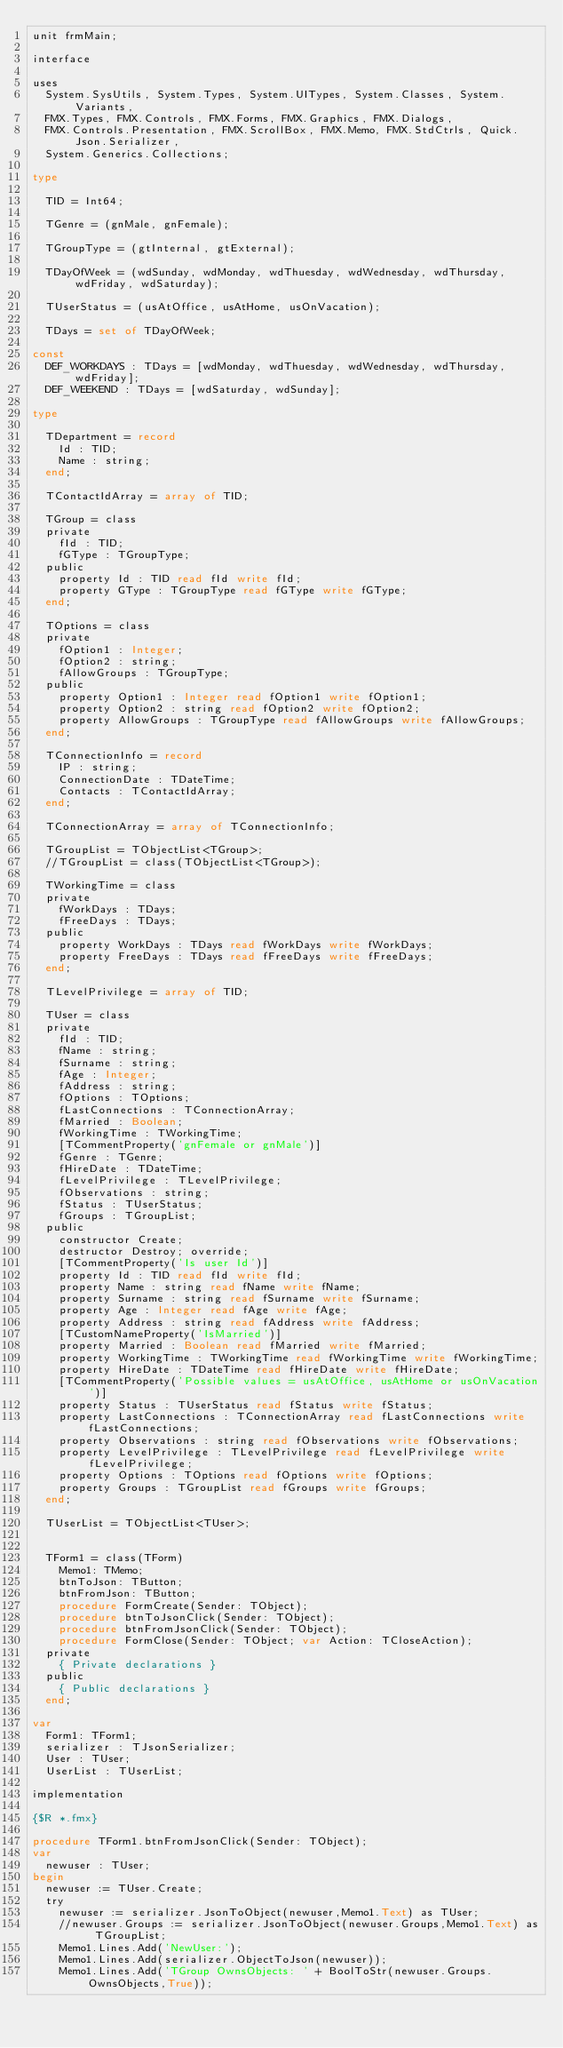Convert code to text. <code><loc_0><loc_0><loc_500><loc_500><_Pascal_>unit frmMain;

interface

uses
  System.SysUtils, System.Types, System.UITypes, System.Classes, System.Variants,
  FMX.Types, FMX.Controls, FMX.Forms, FMX.Graphics, FMX.Dialogs,
  FMX.Controls.Presentation, FMX.ScrollBox, FMX.Memo, FMX.StdCtrls, Quick.Json.Serializer,
  System.Generics.Collections;

type

  TID = Int64;

  TGenre = (gnMale, gnFemale);

  TGroupType = (gtInternal, gtExternal);

  TDayOfWeek = (wdSunday, wdMonday, wdThuesday, wdWednesday, wdThursday, wdFriday, wdSaturday);

  TUserStatus = (usAtOffice, usAtHome, usOnVacation);

  TDays = set of TDayOfWeek;

const
  DEF_WORKDAYS : TDays = [wdMonday, wdThuesday, wdWednesday, wdThursday, wdFriday];
  DEF_WEEKEND : TDays = [wdSaturday, wdSunday];

type

  TDepartment = record
    Id : TID;
    Name : string;
  end;

  TContactIdArray = array of TID;

  TGroup = class
  private
    fId : TID;
    fGType : TGroupType;
  public
    property Id : TID read fId write fId;
    property GType : TGroupType read fGType write fGType;
  end;

  TOptions = class
  private
    fOption1 : Integer;
    fOption2 : string;
    fAllowGroups : TGroupType;
  public
    property Option1 : Integer read fOption1 write fOption1;
    property Option2 : string read fOption2 write fOption2;
    property AllowGroups : TGroupType read fAllowGroups write fAllowGroups;
  end;

  TConnectionInfo = record
    IP : string;
    ConnectionDate : TDateTime;
    Contacts : TContactIdArray;
  end;

  TConnectionArray = array of TConnectionInfo;

  TGroupList = TObjectList<TGroup>;
  //TGroupList = class(TObjectList<TGroup>);

  TWorkingTime = class
  private
    fWorkDays : TDays;
    fFreeDays : TDays;
  public
    property WorkDays : TDays read fWorkDays write fWorkDays;
    property FreeDays : TDays read fFreeDays write fFreeDays;
  end;

  TLevelPrivilege = array of TID;

  TUser = class
  private
    fId : TID;
    fName : string;
    fSurname : string;
    fAge : Integer;
    fAddress : string;
    fOptions : TOptions;
    fLastConnections : TConnectionArray;
    fMarried : Boolean;
    fWorkingTime : TWorkingTime;
    [TCommentProperty('gnFemale or gnMale')]
    fGenre : TGenre;
    fHireDate : TDateTime;
    fLevelPrivilege : TLevelPrivilege;
    fObservations : string;
    fStatus : TUserStatus;
    fGroups : TGroupList;
  public
    constructor Create;
    destructor Destroy; override;
    [TCommentProperty('Is user Id')]
    property Id : TID read fId write fId;
    property Name : string read fName write fName;
    property Surname : string read fSurname write fSurname;
    property Age : Integer read fAge write fAge;
    property Address : string read fAddress write fAddress;
    [TCustomNameProperty('IsMarried')]
    property Married : Boolean read fMarried write fMarried;
    property WorkingTime : TWorkingTime read fWorkingTime write fWorkingTime;
    property HireDate : TDateTime read fHireDate write fHireDate;
    [TCommentProperty('Possible values = usAtOffice, usAtHome or usOnVacation')]
    property Status : TUserStatus read fStatus write fStatus;
    property LastConnections : TConnectionArray read fLastConnections write fLastConnections;
    property Observations : string read fObservations write fObservations;
    property LevelPrivilege : TLevelPrivilege read fLevelPrivilege write fLevelPrivilege;
    property Options : TOptions read fOptions write fOptions;
    property Groups : TGroupList read fGroups write fGroups;
  end;

  TUserList = TObjectList<TUser>;


  TForm1 = class(TForm)
    Memo1: TMemo;
    btnToJson: TButton;
    btnFromJson: TButton;
    procedure FormCreate(Sender: TObject);
    procedure btnToJsonClick(Sender: TObject);
    procedure btnFromJsonClick(Sender: TObject);
    procedure FormClose(Sender: TObject; var Action: TCloseAction);
  private
    { Private declarations }
  public
    { Public declarations }
  end;

var
  Form1: TForm1;
  serializer : TJsonSerializer;
  User : TUser;
  UserList : TUserList;

implementation

{$R *.fmx}

procedure TForm1.btnFromJsonClick(Sender: TObject);
var
  newuser : TUser;
begin
  newuser := TUser.Create;
  try
    newuser := serializer.JsonToObject(newuser,Memo1.Text) as TUser;
    //newuser.Groups := serializer.JsonToObject(newuser.Groups,Memo1.Text) as TGroupList;
    Memo1.Lines.Add('NewUser:');
    Memo1.Lines.Add(serializer.ObjectToJson(newuser));
    Memo1.Lines.Add('TGroup OwnsObjects: ' + BoolToStr(newuser.Groups.OwnsObjects,True));</code> 